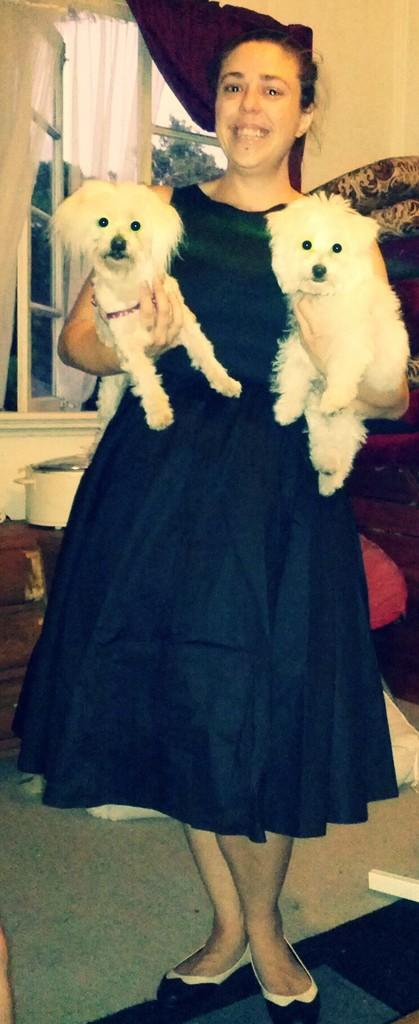What can be seen in the image? There is a person in the room. What is the person wearing? The person is wearing a black dress. What is the person holding in the image? The person is holding two white dogs. What architectural feature is present in the room? There is a window in the room. What type of window treatment is present in the room? There are curtains associated with the window. What arithmetic problem is the person solving in the image? There is no indication in the image that the person is solving an arithmetic problem. 